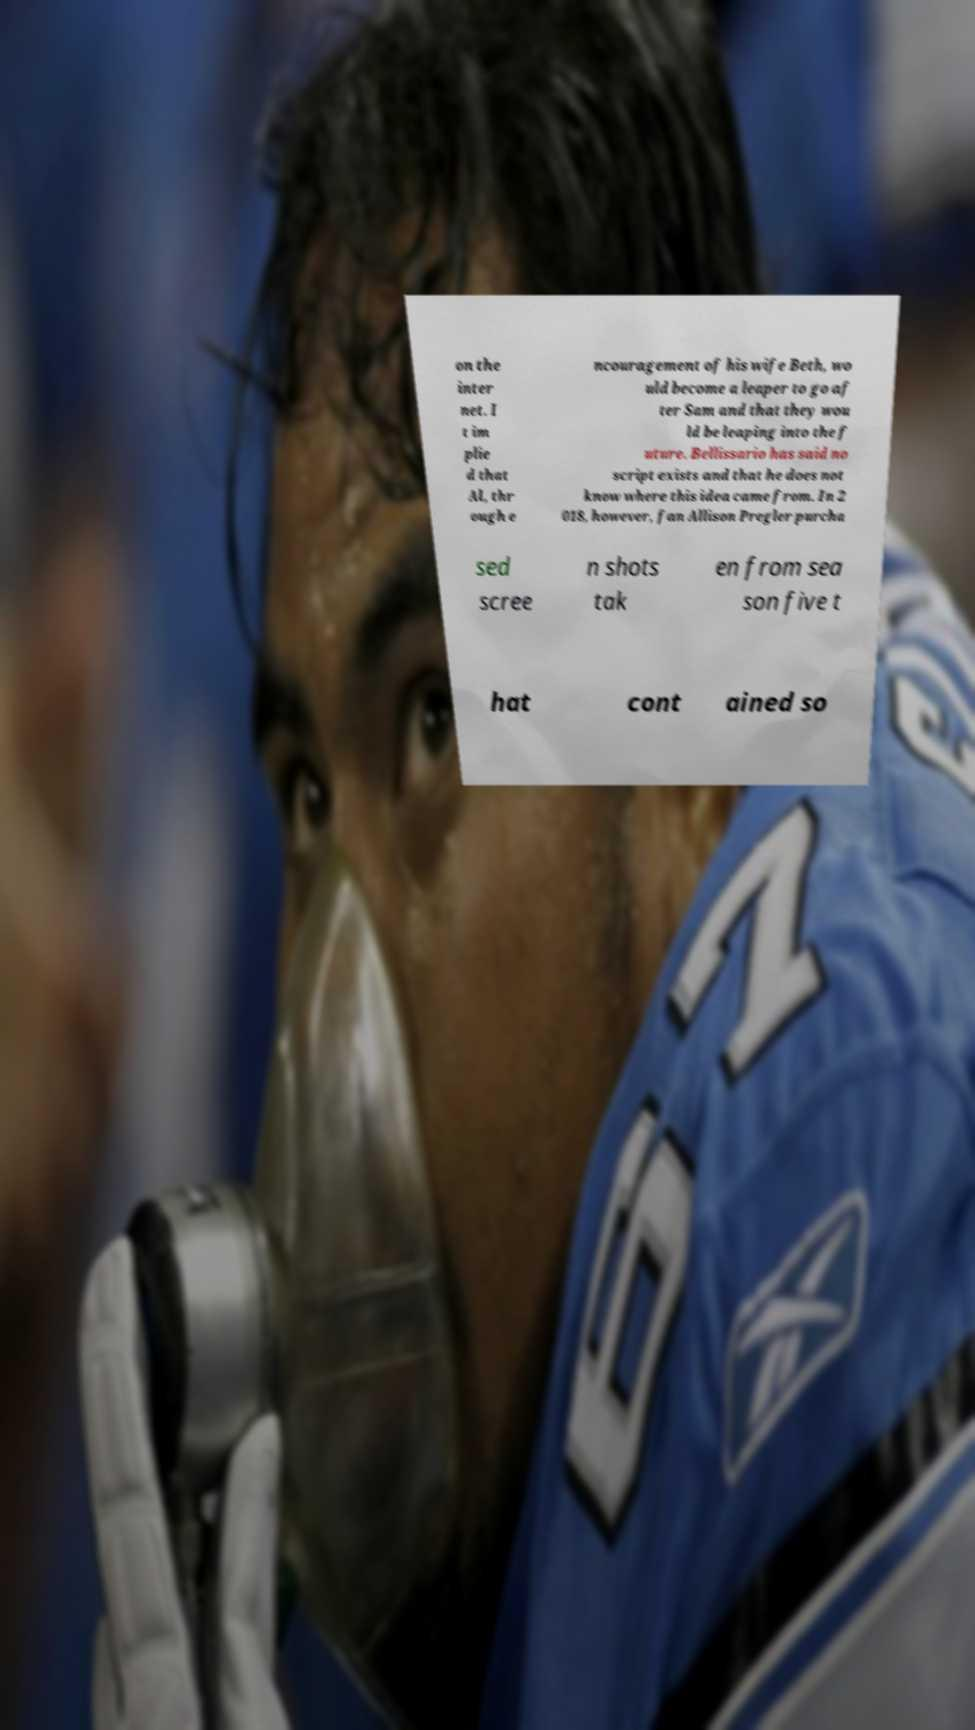Please identify and transcribe the text found in this image. on the inter net. I t im plie d that Al, thr ough e ncouragement of his wife Beth, wo uld become a leaper to go af ter Sam and that they wou ld be leaping into the f uture. Bellissario has said no script exists and that he does not know where this idea came from. In 2 018, however, fan Allison Pregler purcha sed scree n shots tak en from sea son five t hat cont ained so 